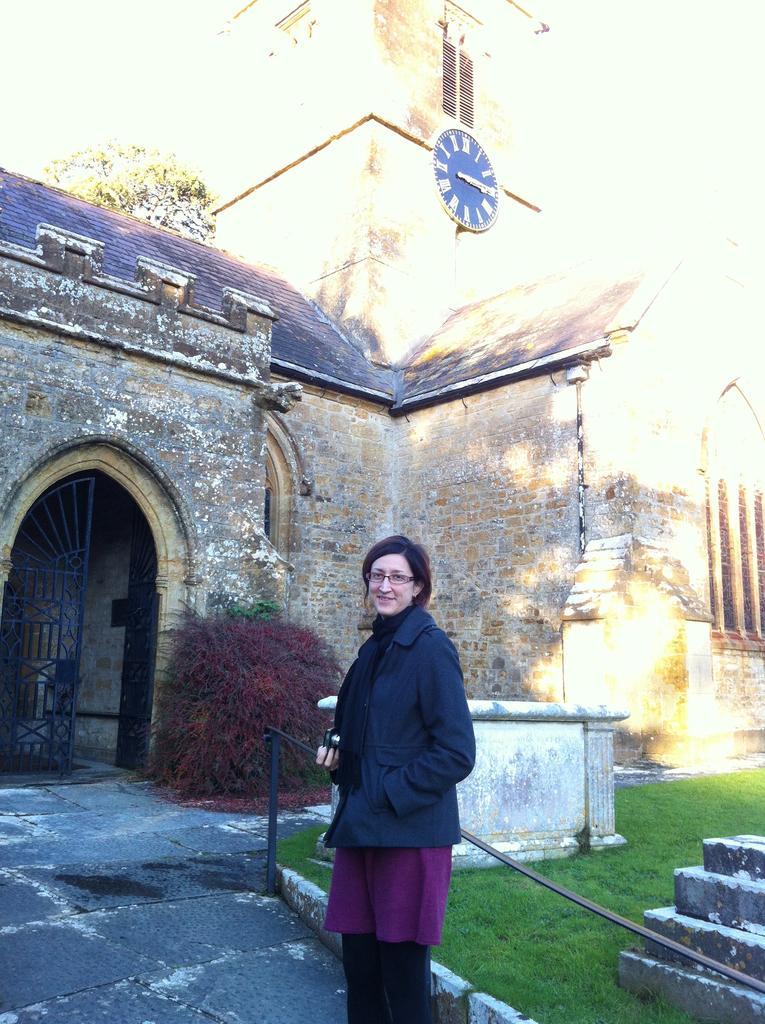In one or two sentences, can you explain what this image depicts? This is the picture of a building. In this image there is a building and there is a clock on the wall. In the foreground there is a woman standing and smiling. At the back there is a door and there are trees. At the bottom there is grass. 